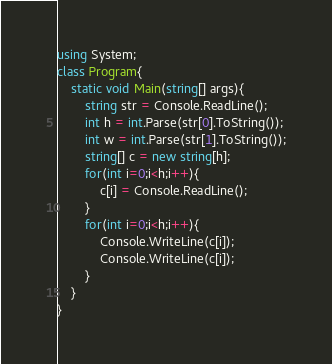Convert code to text. <code><loc_0><loc_0><loc_500><loc_500><_C#_>using System;
class Program{
    static void Main(string[] args){
        string str = Console.ReadLine();
        int h = int.Parse(str[0].ToString());
        int w = int.Parse(str[1].ToString());
        string[] c = new string[h];
        for(int i=0;i<h;i++){
            c[i] = Console.ReadLine();
        }
        for(int i=0;i<h;i++){
            Console.WriteLine(c[i]);
            Console.WriteLine(c[i]);
        }
    }
}</code> 